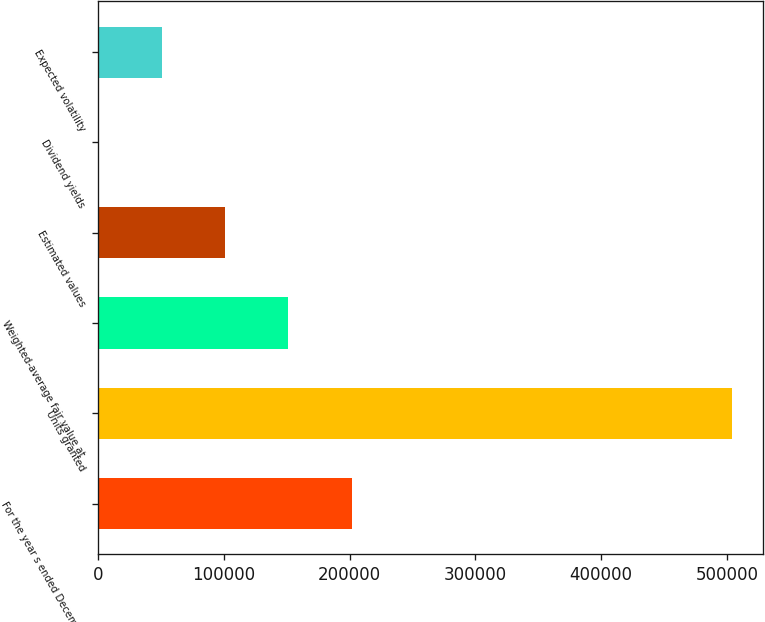Convert chart. <chart><loc_0><loc_0><loc_500><loc_500><bar_chart><fcel>For the year s ended December<fcel>Units granted<fcel>Weighted-average fair value at<fcel>Estimated values<fcel>Dividend yields<fcel>Expected volatility<nl><fcel>201506<fcel>503761<fcel>151130<fcel>100754<fcel>2.5<fcel>50378.3<nl></chart> 